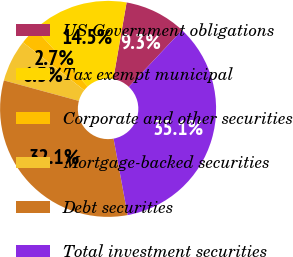Convert chart. <chart><loc_0><loc_0><loc_500><loc_500><pie_chart><fcel>US Government obligations<fcel>Tax exempt municipal<fcel>Corporate and other securities<fcel>Mortgage-backed securities<fcel>Debt securities<fcel>Total investment securities<nl><fcel>9.27%<fcel>14.5%<fcel>2.68%<fcel>6.32%<fcel>32.14%<fcel>35.09%<nl></chart> 